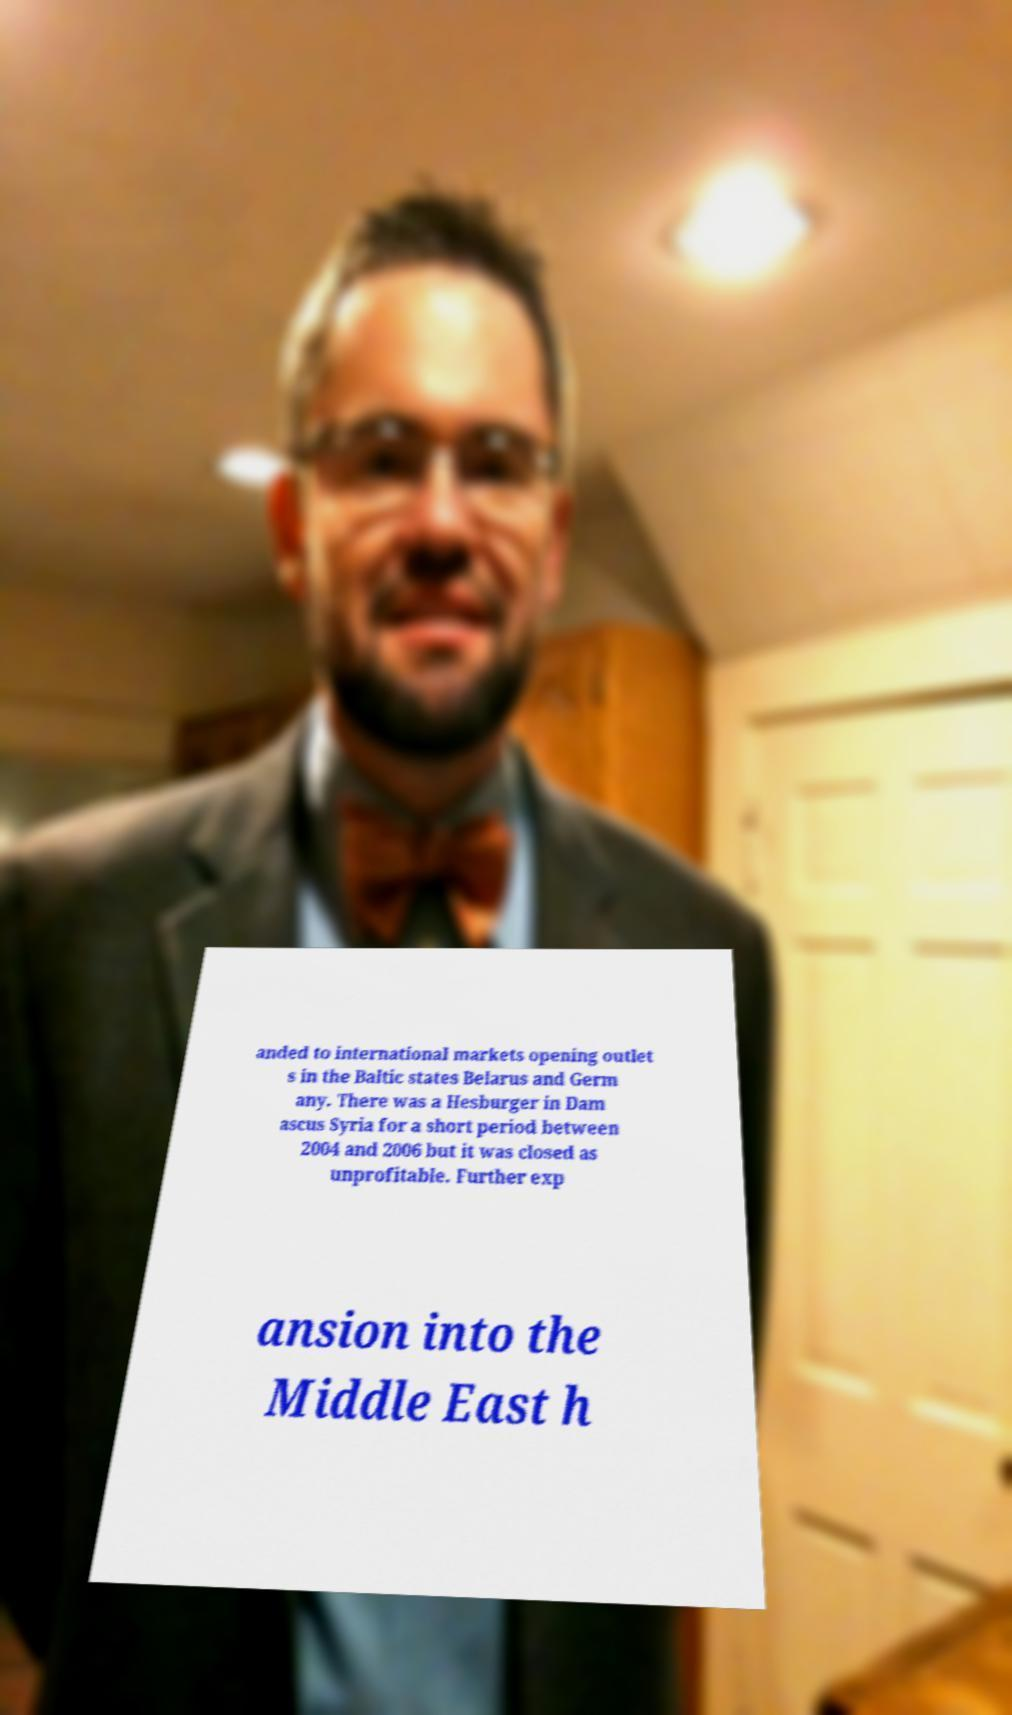Could you extract and type out the text from this image? anded to international markets opening outlet s in the Baltic states Belarus and Germ any. There was a Hesburger in Dam ascus Syria for a short period between 2004 and 2006 but it was closed as unprofitable. Further exp ansion into the Middle East h 